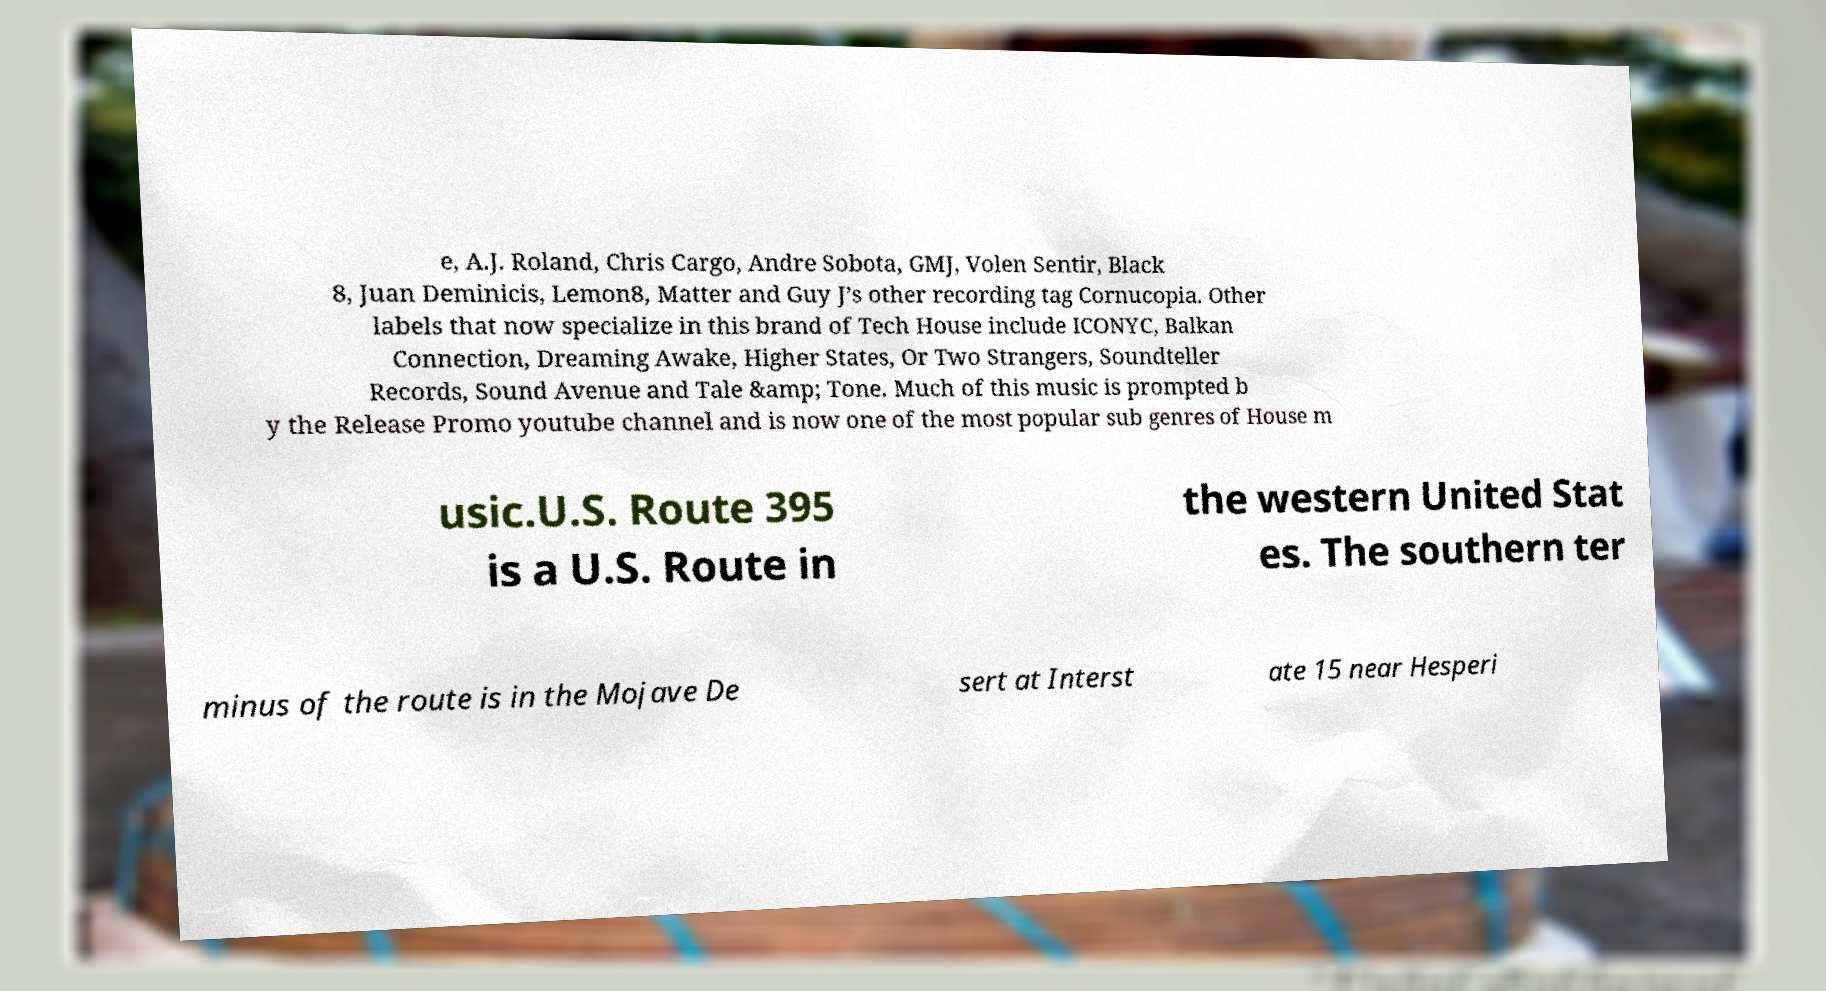There's text embedded in this image that I need extracted. Can you transcribe it verbatim? e, A.J. Roland, Chris Cargo, Andre Sobota, GMJ, Volen Sentir, Black 8, Juan Deminicis, Lemon8, Matter and Guy J’s other recording tag Cornucopia. Other labels that now specialize in this brand of Tech House include ICONYC, Balkan Connection, Dreaming Awake, Higher States, Or Two Strangers, Soundteller Records, Sound Avenue and Tale &amp; Tone. Much of this music is prompted b y the Release Promo youtube channel and is now one of the most popular sub genres of House m usic.U.S. Route 395 is a U.S. Route in the western United Stat es. The southern ter minus of the route is in the Mojave De sert at Interst ate 15 near Hesperi 